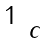<formula> <loc_0><loc_0><loc_500><loc_500>\begin{smallmatrix} 1 \\ & c \end{smallmatrix}</formula> 